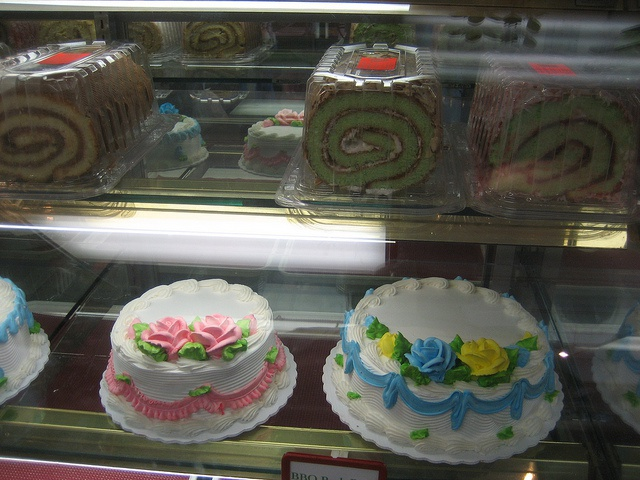Describe the objects in this image and their specific colors. I can see cake in beige, gray, darkgray, blue, and olive tones, cake in beige, gray, lightgray, darkgray, and brown tones, cake in beige, black, darkgreen, and gray tones, cake in beige, black, and gray tones, and cake in beige, black, and gray tones in this image. 